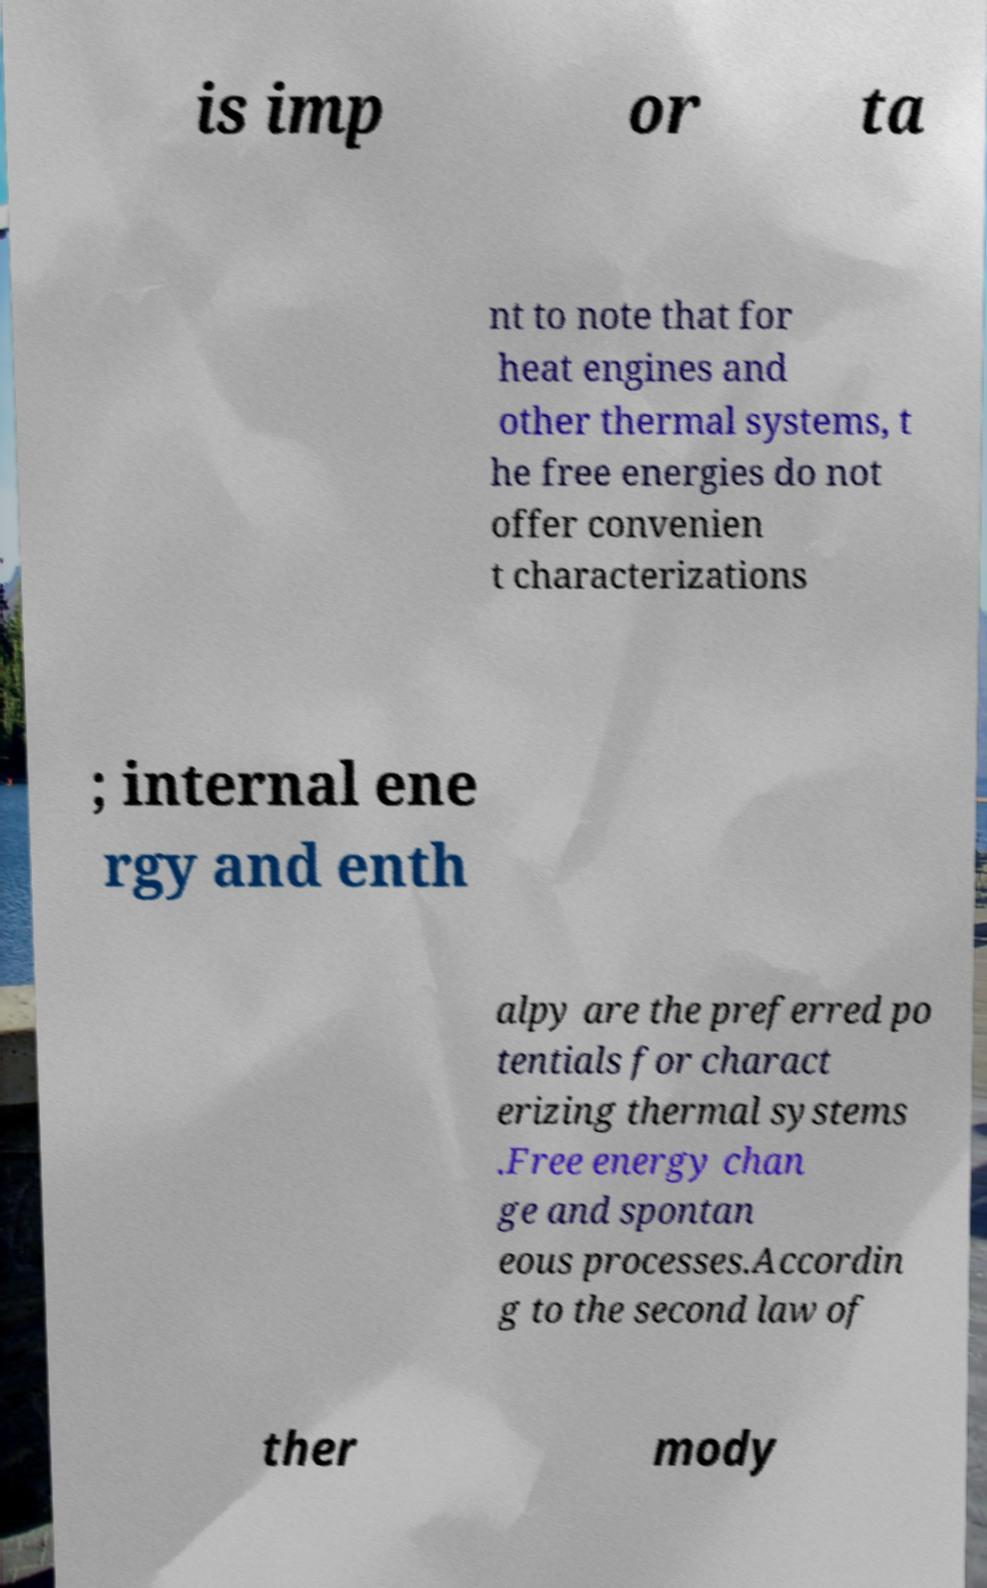There's text embedded in this image that I need extracted. Can you transcribe it verbatim? is imp or ta nt to note that for heat engines and other thermal systems, t he free energies do not offer convenien t characterizations ; internal ene rgy and enth alpy are the preferred po tentials for charact erizing thermal systems .Free energy chan ge and spontan eous processes.Accordin g to the second law of ther mody 